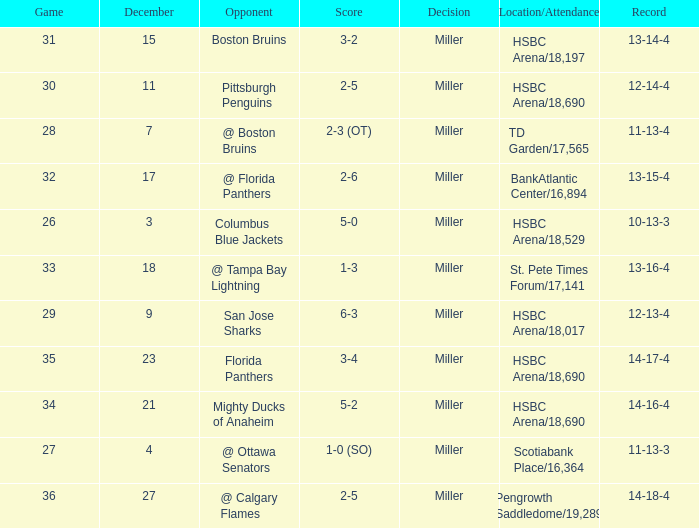Name the least december for hsbc arena/18,017 9.0. 